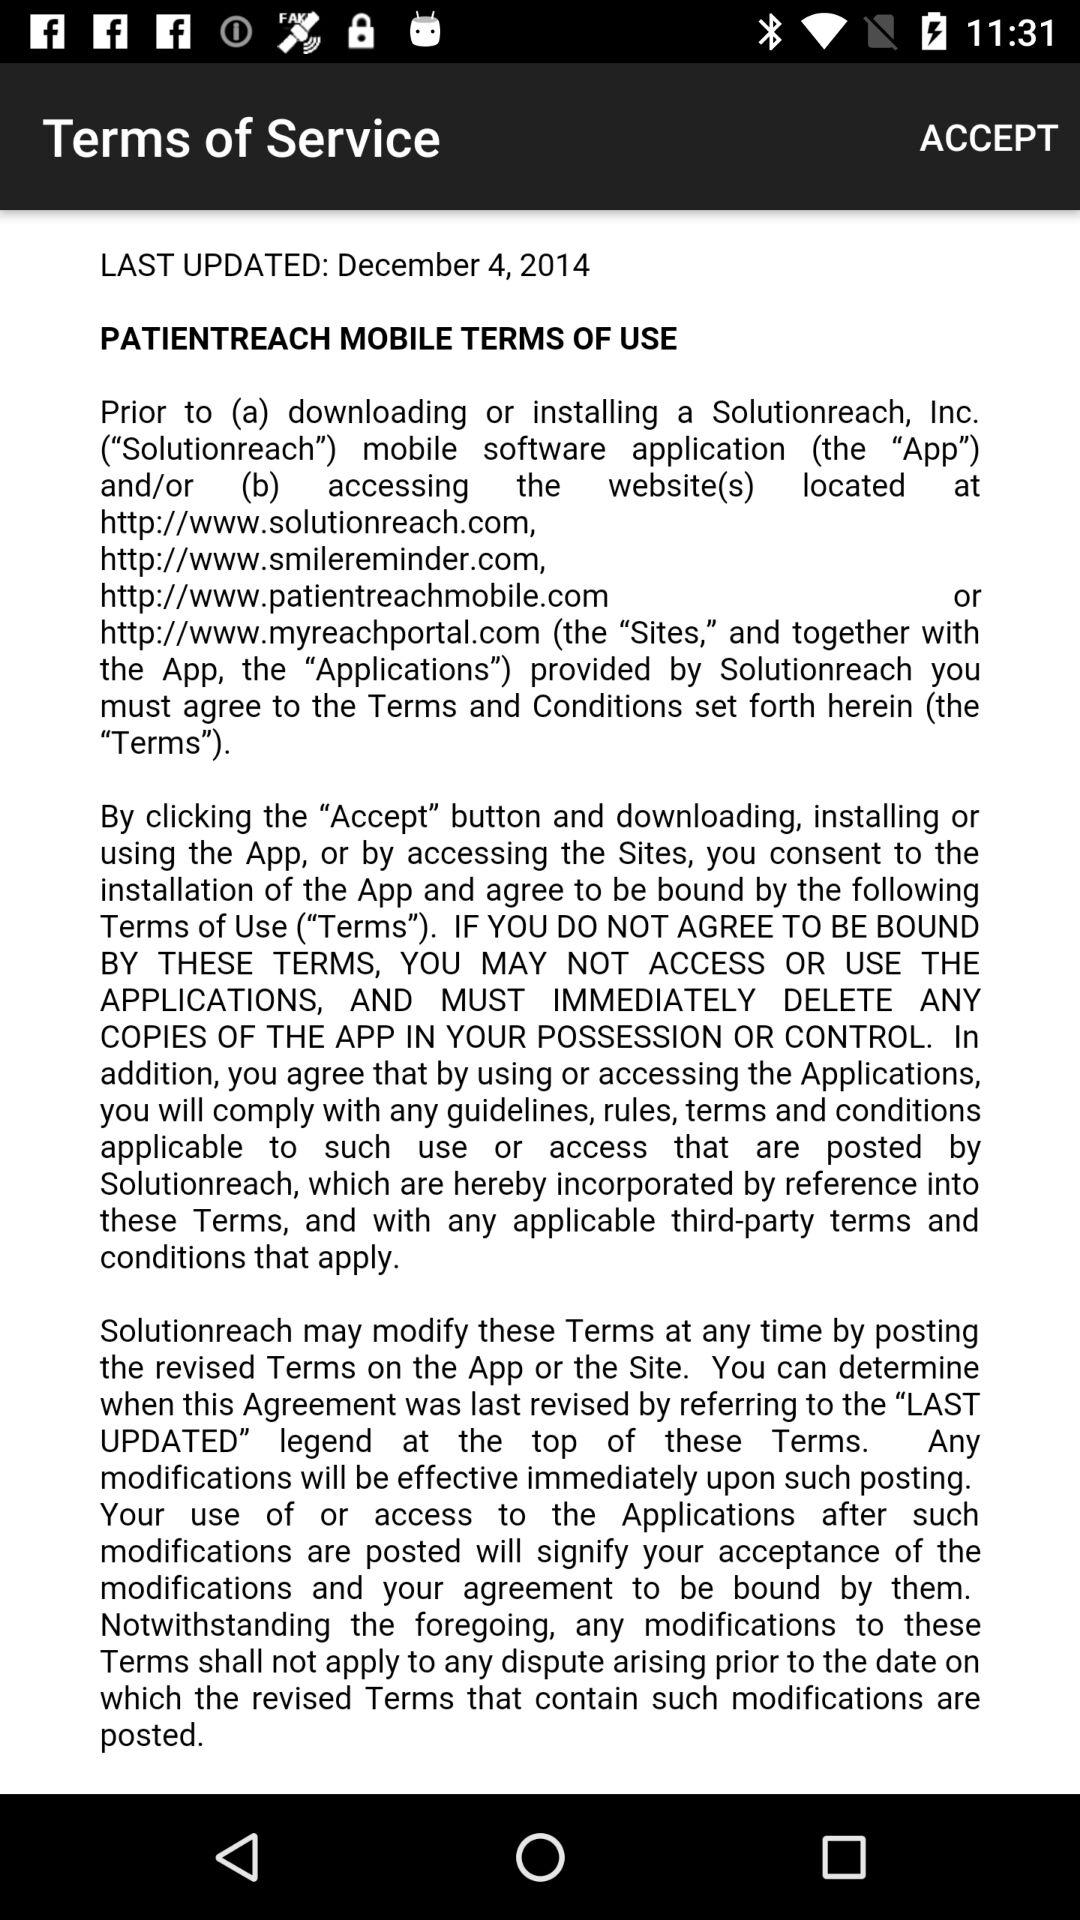When were the terms of service last updated? The terms of service were last updated on December 4, 2014. 